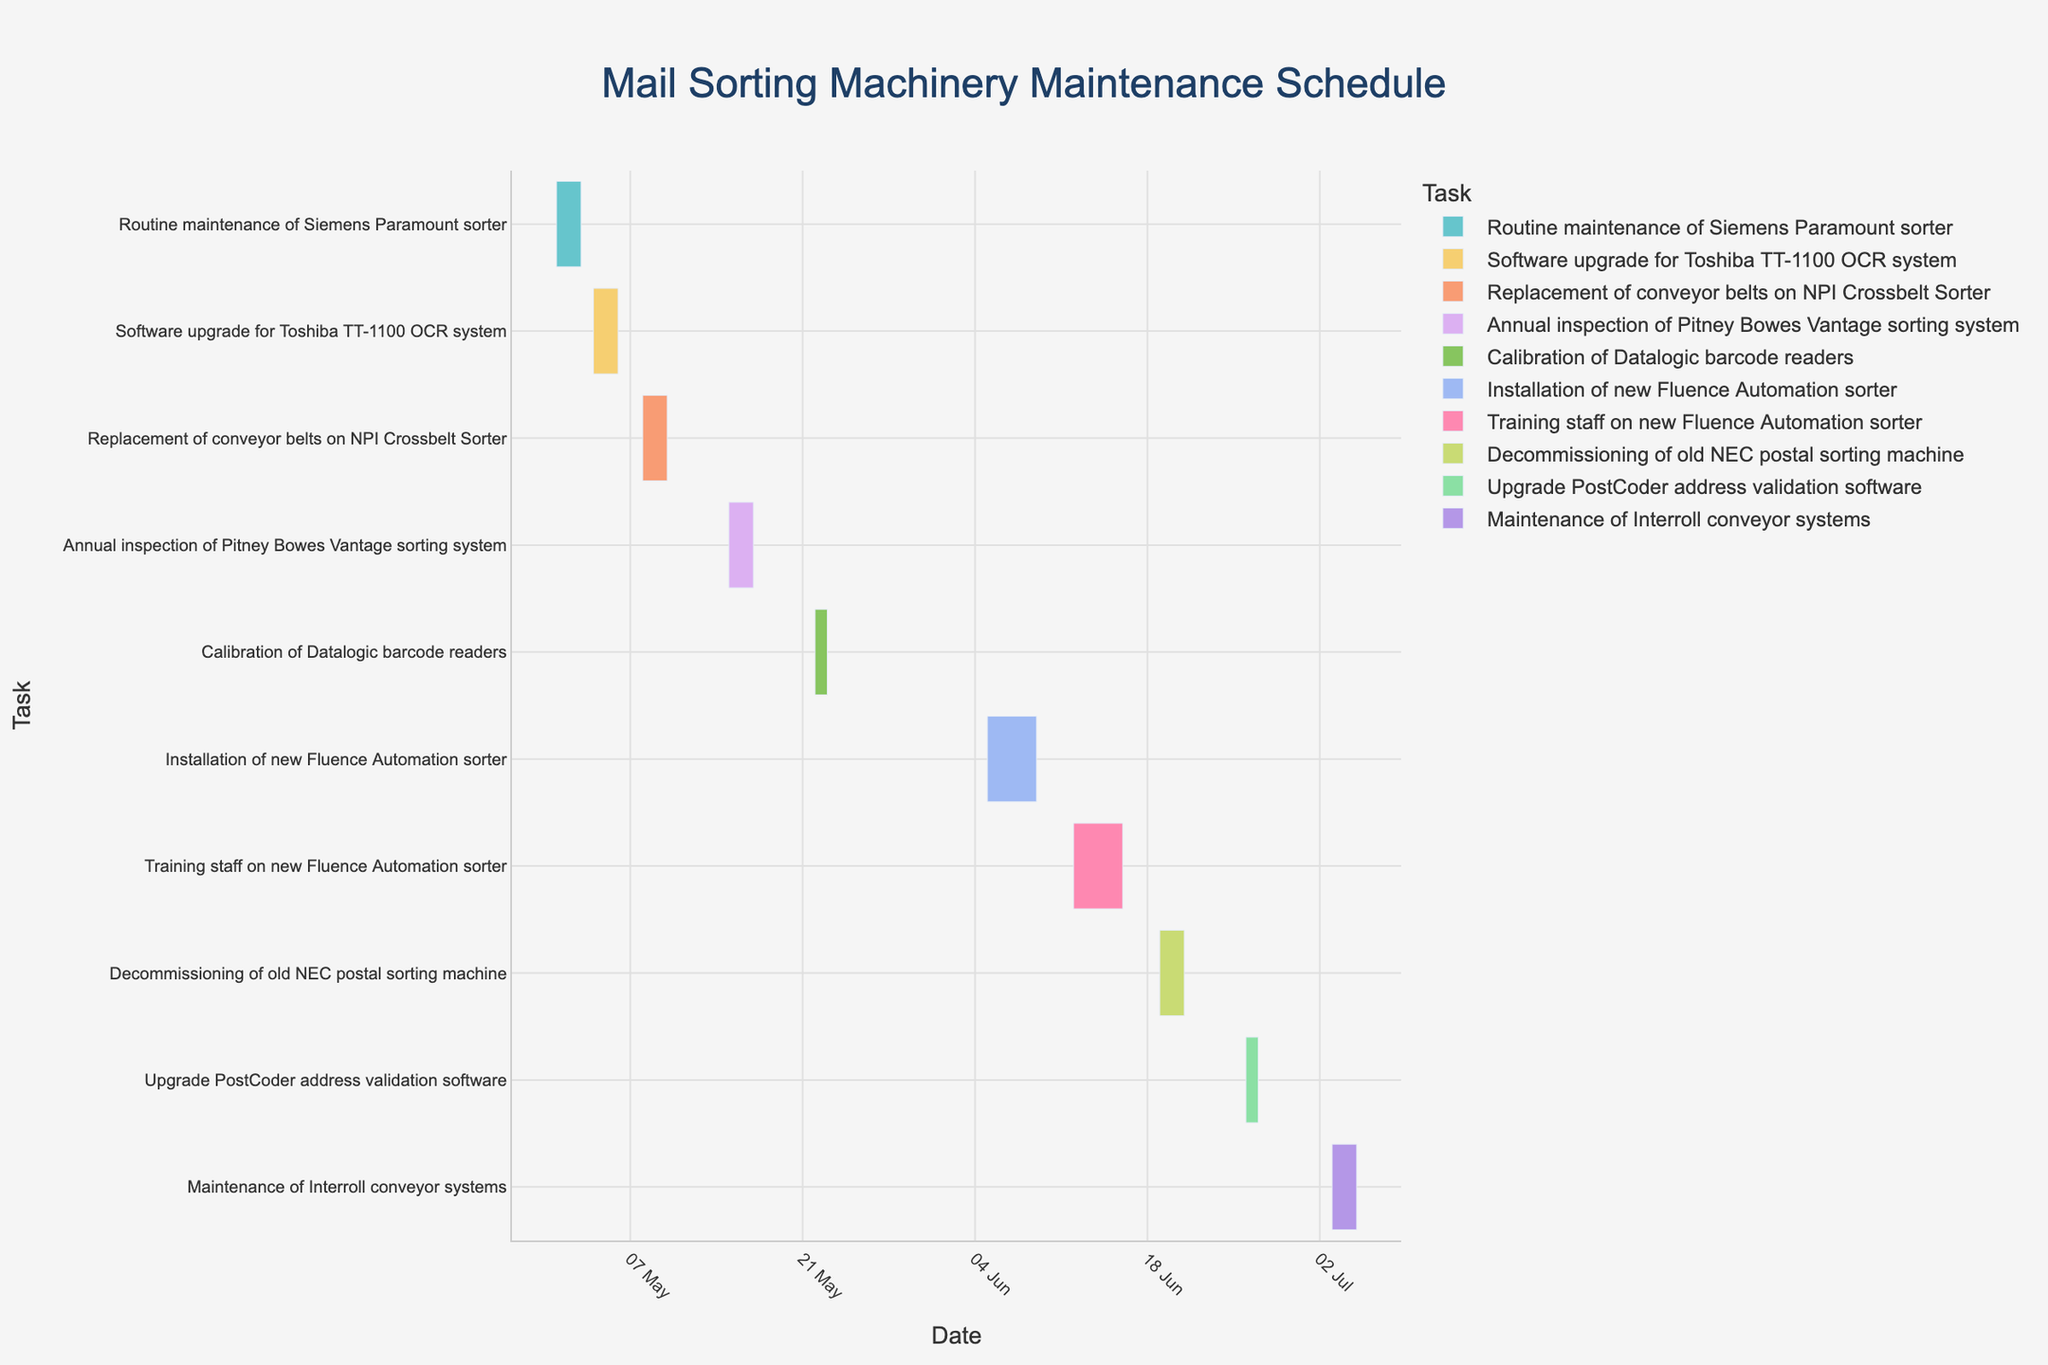What is the total duration of the installation of the new Fluence Automation sorter? The installation of the new Fluence Automation sorter starts on 5th June 2023 and ends on 9th June 2023. This period includes 5 days (5th, 6th, 7th, 8th, and 9th June).
Answer: 5 days Which task has the shortest duration? The chart shows the duration of each task visually. The shortest duration is for the Calibration of Datalogic barcode readers, and the task takes place from 22nd May 2023 to 23rd May 2023, so it runs for 2 days.
Answer: Calibration of Datalogic barcode readers How many tasks are scheduled in June 2023? By looking at the figure, the tasks scheduled in June 2023 are Installation of new Fluence Automation sorter, Training staff on new Fluence Automation sorter, Decommissioning of old NEC postal sorting machine, and Upgrade PostCoder address validation software. Therefore, there are 4 tasks in June.
Answer: 4 What is the duration of the entire maintenance and upgrade schedule? The first task, Routine Maintenance of Siemens Paramount sorter, starts on 1st May 2023, and the last task, Maintenance of Interroll conveyor systems, ends on 5th July 2023. Therefore, the entire schedule spans from 1st May to 5th July, which is a total of 66 days.
Answer: 66 days Which task ends on the same day it begins? By examining the figure, there are no tasks that start and end on the same day.
Answer: None Which tasks have a duration longer than 3 days? By examining the chart, the tasks that have a duration longer than 3 days are:
1. Installation of new Fluence Automation sorter (5 days) 
2. Training staff on new Fluence Automation sorter (5 days).
Answer: Installation of new Fluence Automation sorter, Training staff on new Fluence Automation sorter Which month has the highest number of scheduled tasks? By counting the number of tasks in each month: May has 4 tasks, June has 4 tasks, and July has 1 task. Therefore, both May and June have the highest number with 4 tasks each.
Answer: May and June Which two tasks have the longest and shortest durations respectively? By examining the start and end dates, the task with the longest duration is the Installation of new Fluence Automation sorter (5 days), and with the shortest duration is Calibration of Datalogic barcode readers (2 days).
Answer: Installation of new Fluence Automation sorter (longest), Calibration of Datalogic barcode readers (shortest) What is the total duration of the tasks scheduled from 1st June 2023 to 30th June 2023? The tasks within June are: 
1. Installation of new Fluence Automation sorter (5 days)
2. Training staff on new Fluence Automation sorter (5 days)
3. Decommissioning of old NEC postal sorting machine (3 days)
4. Upgrade PostCoder address validation software (2 days)
So total duration in June = 5 + 5 + 3 + 2 = 15 days.
Answer: 15 days 